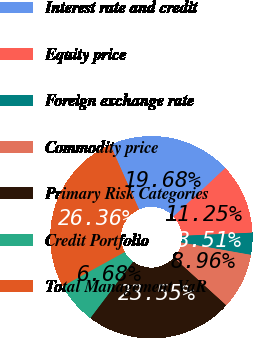Convert chart to OTSL. <chart><loc_0><loc_0><loc_500><loc_500><pie_chart><fcel>Interest rate and credit<fcel>Equity price<fcel>Foreign exchange rate<fcel>Commodity price<fcel>Primary Risk Categories<fcel>Credit Portfolio<fcel>Total Management VaR<nl><fcel>19.68%<fcel>11.25%<fcel>3.51%<fcel>8.96%<fcel>23.55%<fcel>6.68%<fcel>26.36%<nl></chart> 